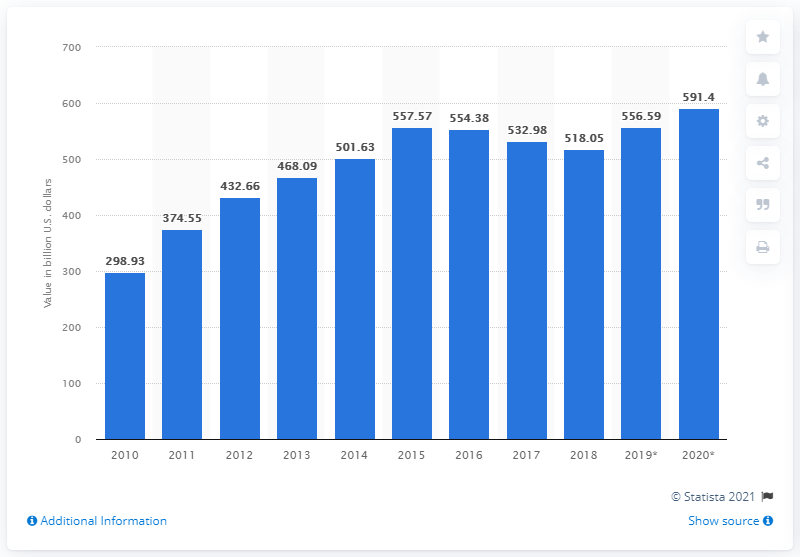Draw attention to some important aspects in this diagram. It is estimated that by 2020, the amount of external debt service in Latin American and Caribbean countries will be approximately 591.4. In 2010, the total amount of foreign debt service was 298.93. 